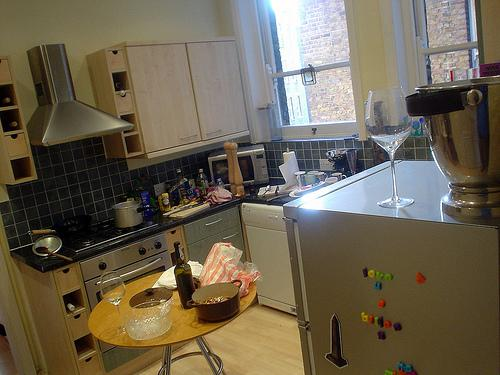Question: what room is this?
Choices:
A. Bedroom.
B. Bathroom.
C. Kitchen.
D. Office.
Answer with the letter. Answer: C Question: what is in the bottle?
Choices:
A. Beer.
B. Milk.
C. Soda.
D. Wine.
Answer with the letter. Answer: D Question: why is there a glare on the fridge?
Choices:
A. It's metal.
B. Suns reflection.
C. From moonlight.
D. From the window.
Answer with the letter. Answer: B Question: what is brown?
Choices:
A. Rug.
B. Drapes.
C. Table.
D. Walls.
Answer with the letter. Answer: C 